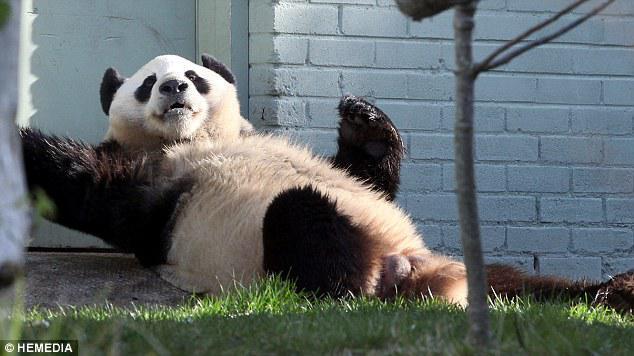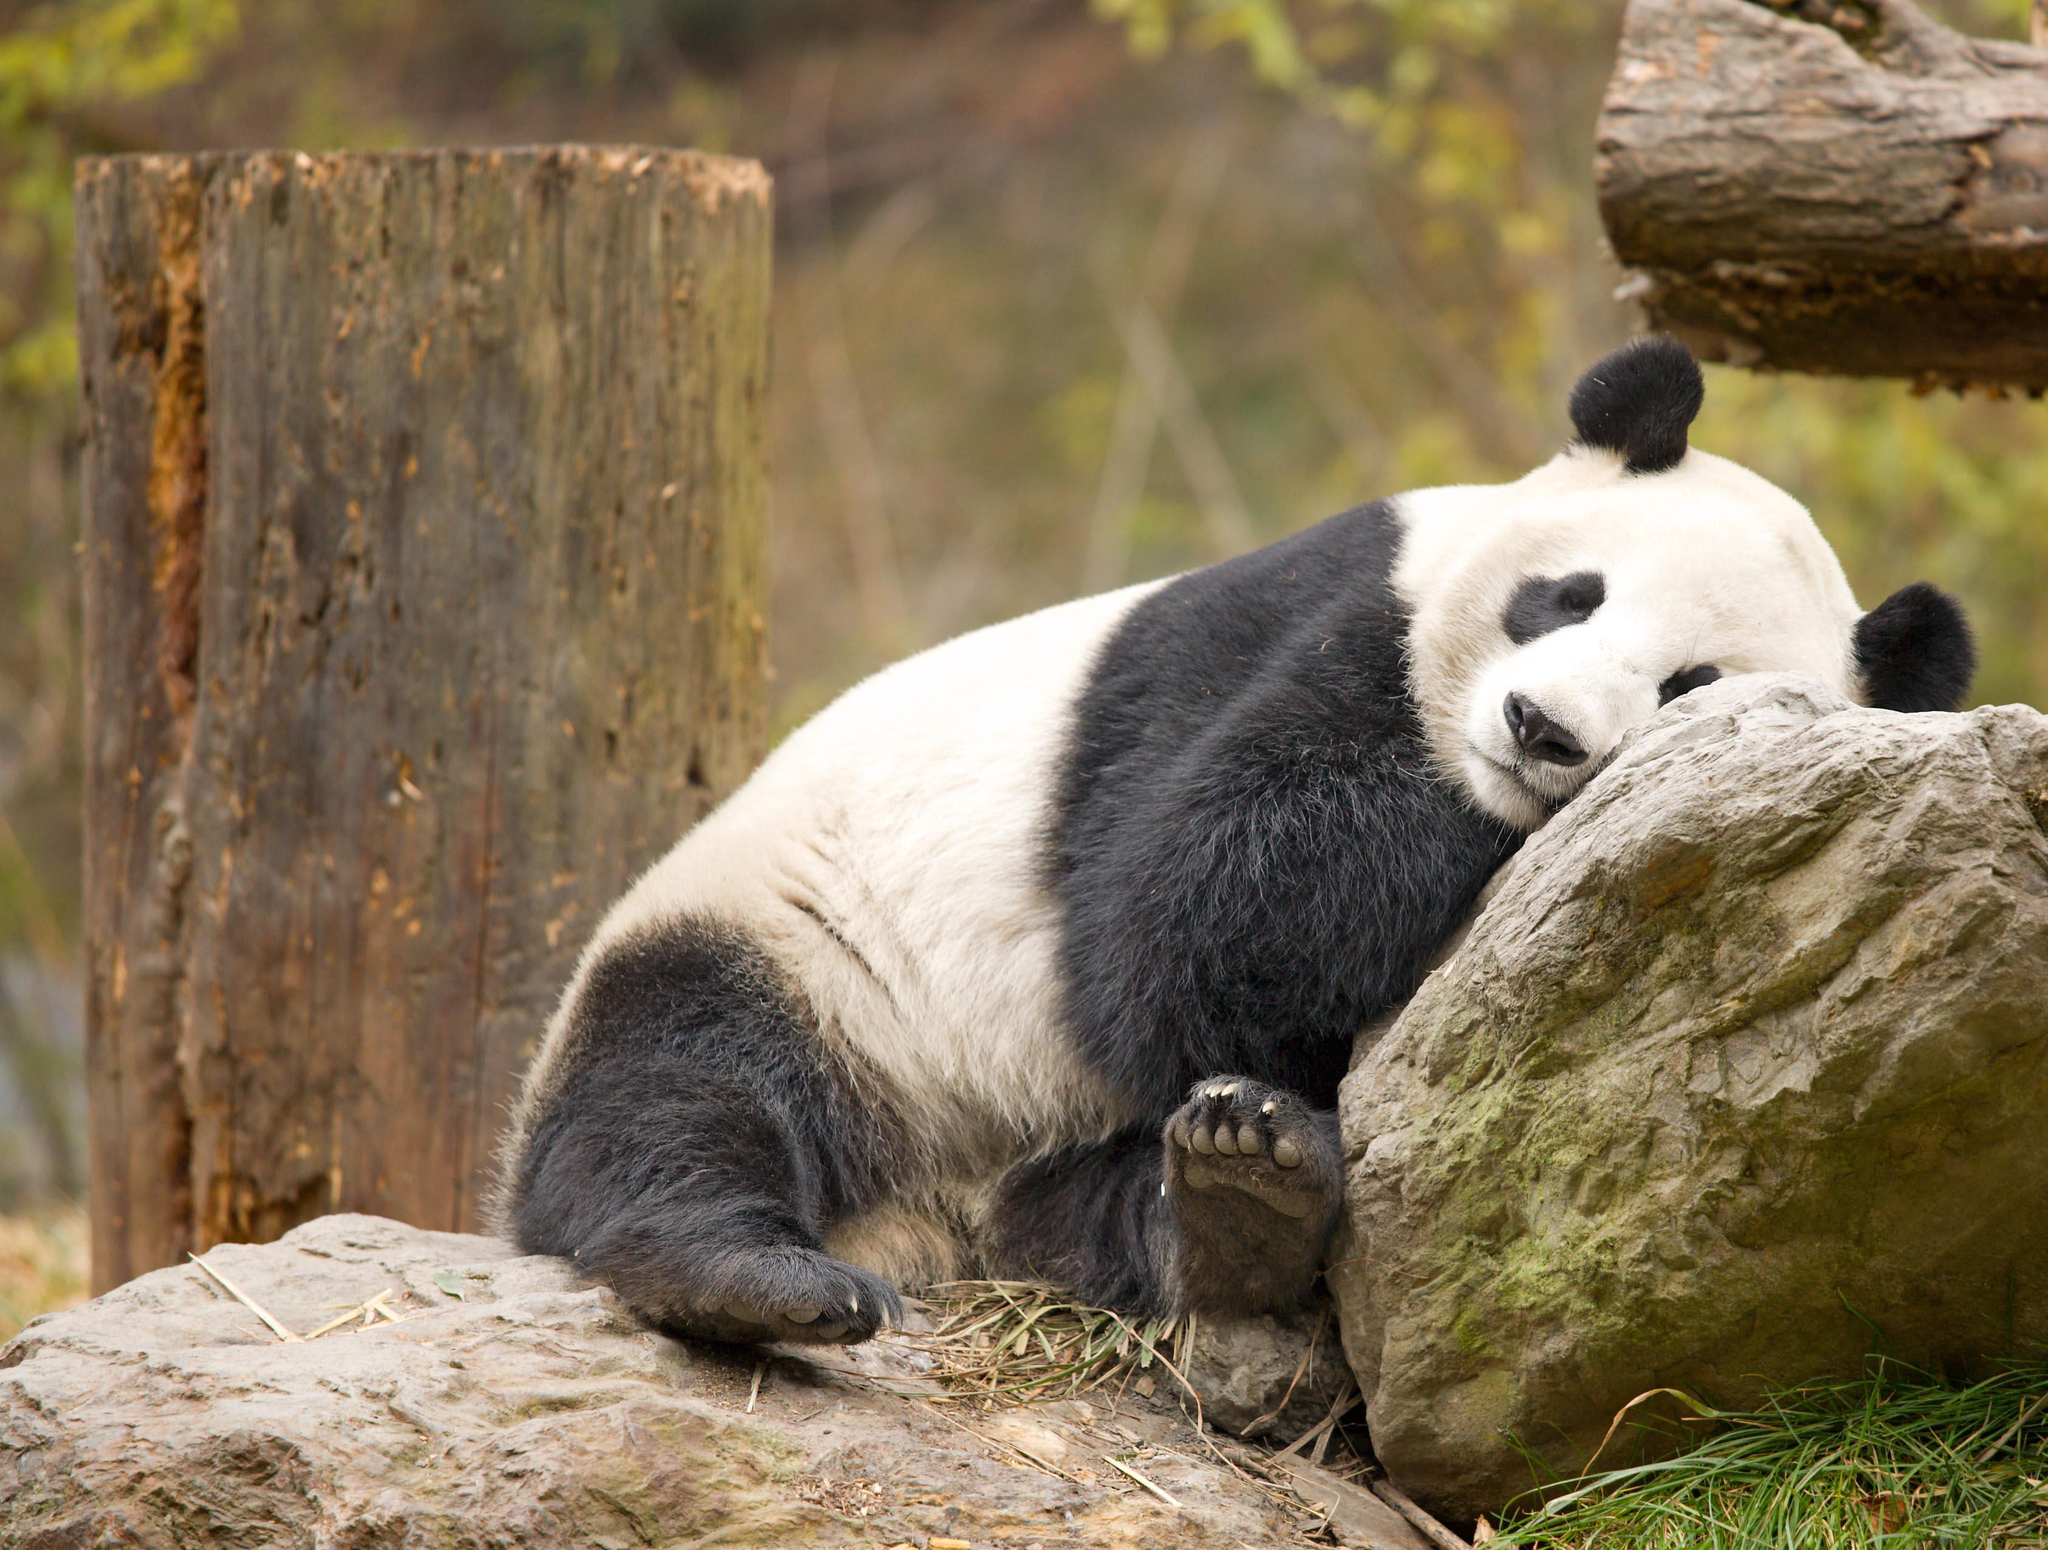The first image is the image on the left, the second image is the image on the right. Evaluate the accuracy of this statement regarding the images: "An image contains a single panda bear, which lies on its back with at least two paws off the ground.". Is it true? Answer yes or no. Yes. The first image is the image on the left, the second image is the image on the right. Considering the images on both sides, is "Two pandas are sitting to eat in at least one of the images." valid? Answer yes or no. No. 